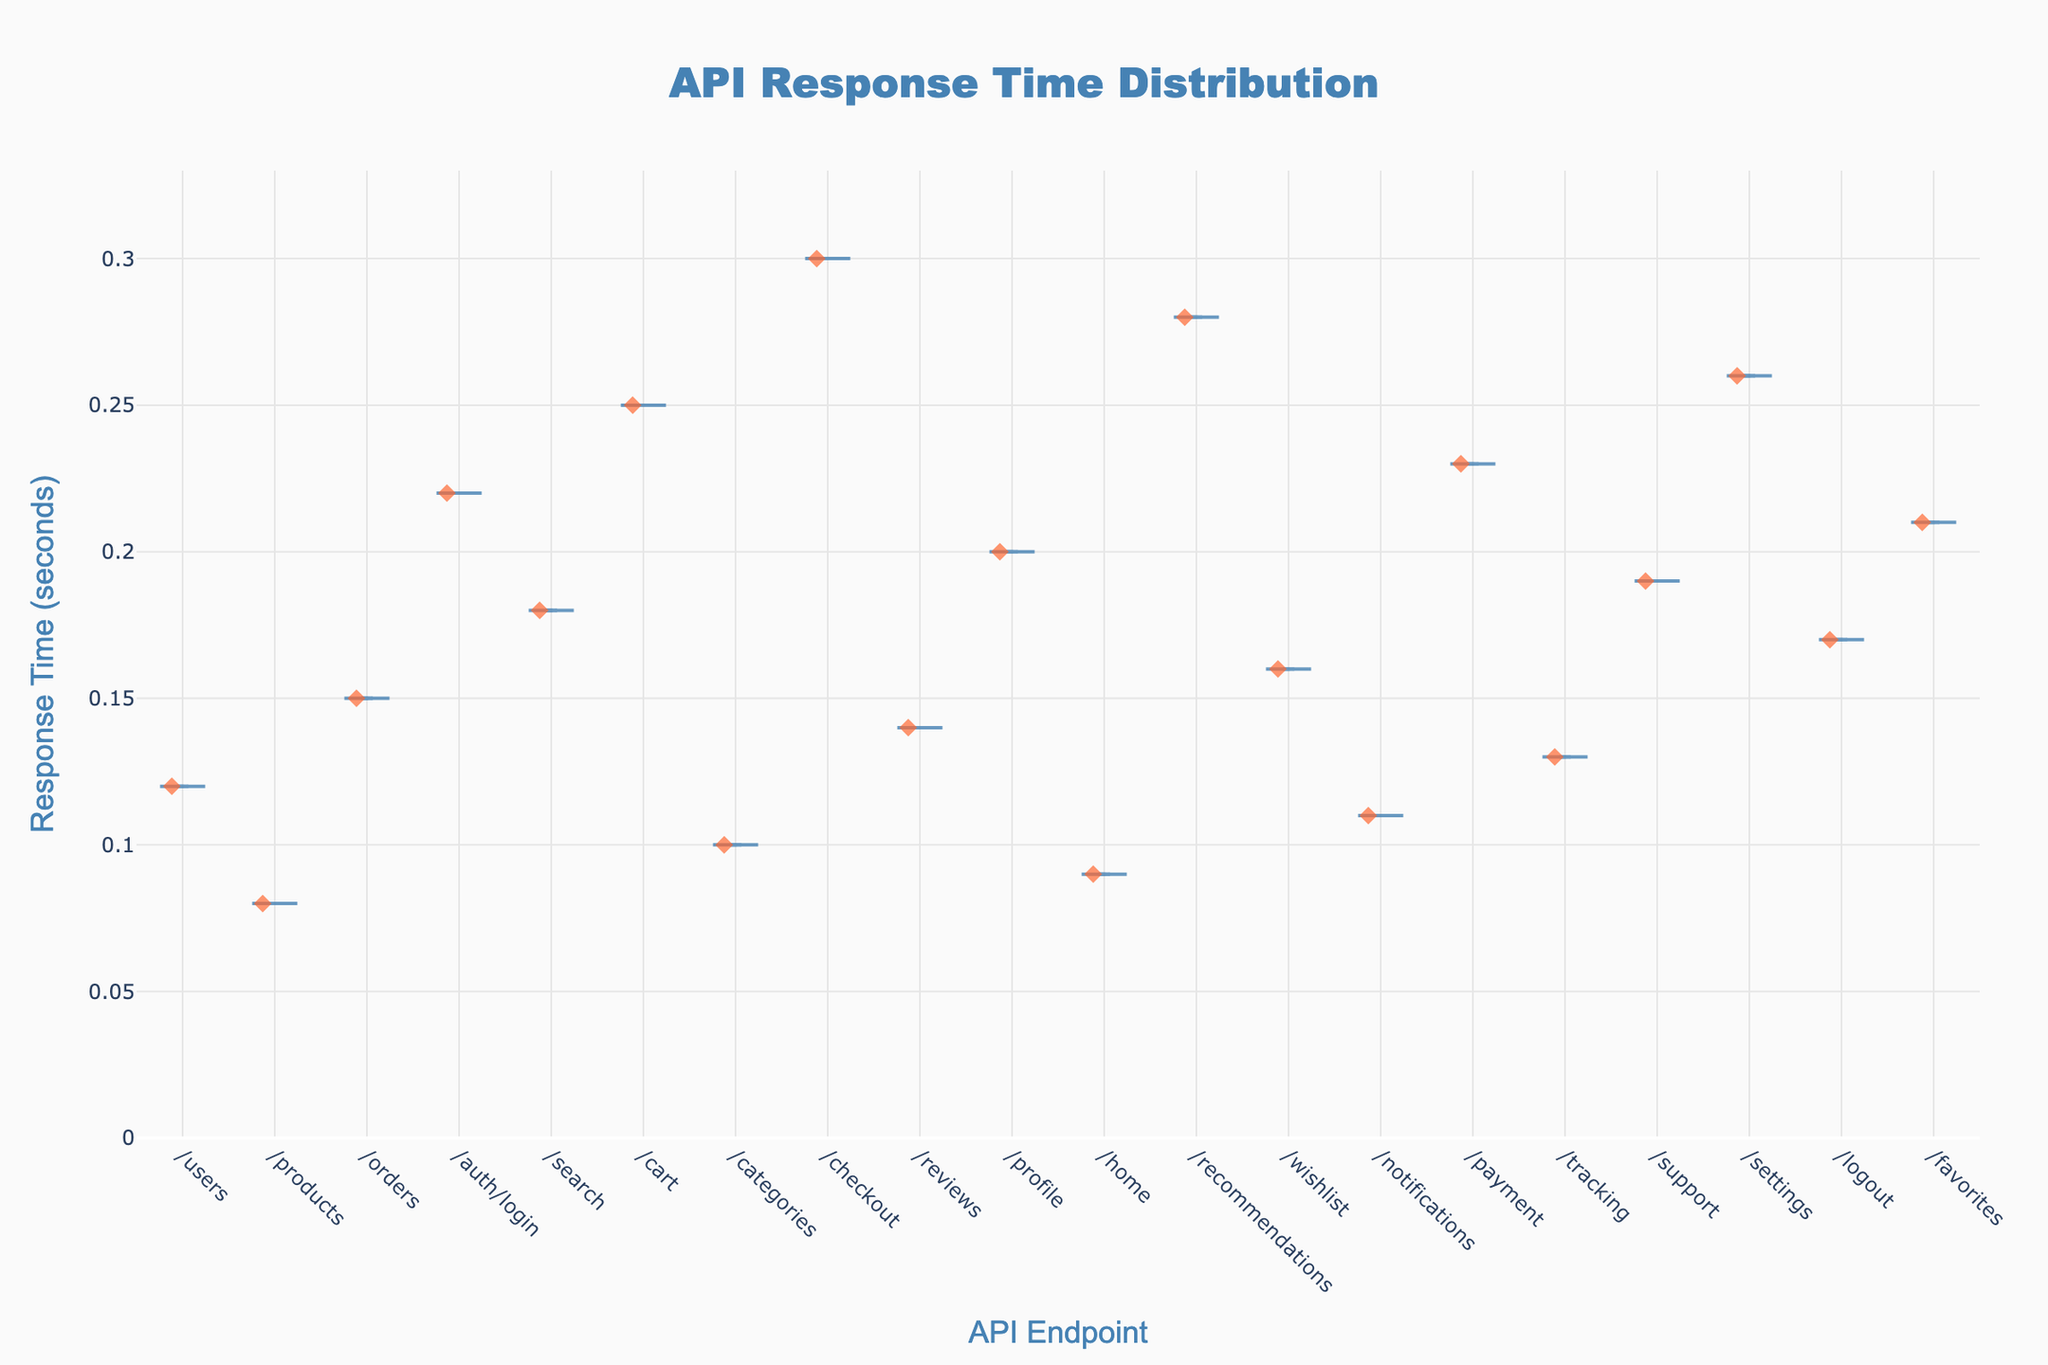what is the title of the figure? The title of the figure is usually displayed prominently at the top of the plot. In this figure, the title reads "API Response Time Distribution" which is centered and styled.
Answer: API Response Time Distribution What does the x-axis represent? The x-axis represents different categories or groups across the bottom of the chart, in this figure they represent various API endpoints of a web application.
Answer: API Endpoints Which endpoint has the highest response time? By examining the plot, we look for the data point furthest up on the y-axis. The endpoint "/checkout" displays the highest response time.
Answer: /checkout What is the range of the y-axis? Typically, the y-axis range is displayed on the left of the plot. For this figure, the range is from 0 to approximately 0.33 seconds.
Answer: 0 to 0.33 seconds How many data points are at the "/auth/login" endpoint? Each data point on a violin plot is usually represented by a different marker. By counting the markers at "/auth/login", there is only one.
Answer: 1 What is the mean response time for the "/products" endpoint? The mean response line is drawn inside each violin plot. For "/products", the mean response time matches the central line around 0.08 seconds.
Answer: 0.08 seconds Which endpoints have response times greater than 0.25 seconds? By examining the y-axis and identifying points above 0.25 seconds, the endpoints are "/checkout", "/recommendations", and "/settings".
Answer: /checkout, /recommendations, /settings Compare the response times between "/cart" and "/profile" endpoints. Which one is faster? By comparing the response times, "/cart" appears to have higher response times since its points lie above those of "/profile". Therefore, "/profile" is faster.
Answer: /profile What does the color of the markers indicate? In the plot, the markers are colored differently for visual distinction. The orange-red color of the markers indicates the individual response times for API calls.
Answer: Response times What is the median response time for the "/notifications" endpoint? The median line or point is usually at the middle of the distribution in violin plots. For "/notifications", it appears to be around 0.11 seconds.
Answer: 0.11 seconds 